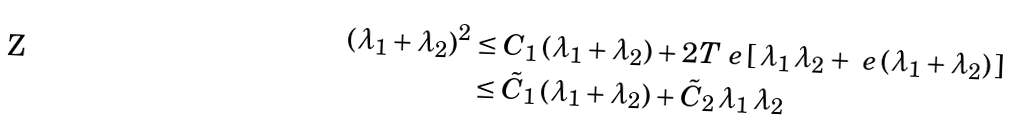Convert formula to latex. <formula><loc_0><loc_0><loc_500><loc_500>( \lambda _ { 1 } + \lambda _ { 2 } ) ^ { 2 } & \leq C _ { 1 } \, ( \lambda _ { 1 } + \lambda _ { 2 } ) + 2 T _ { \ } e \, [ \, \lambda _ { 1 } \, \lambda _ { 2 } + \ e \, ( \lambda _ { 1 } + \lambda _ { 2 } ) \, ] \\ & \leq \tilde { C } _ { 1 } \, ( \lambda _ { 1 } + \lambda _ { 2 } ) + \tilde { C } _ { 2 } \, \lambda _ { 1 } \, \lambda _ { 2 }</formula> 